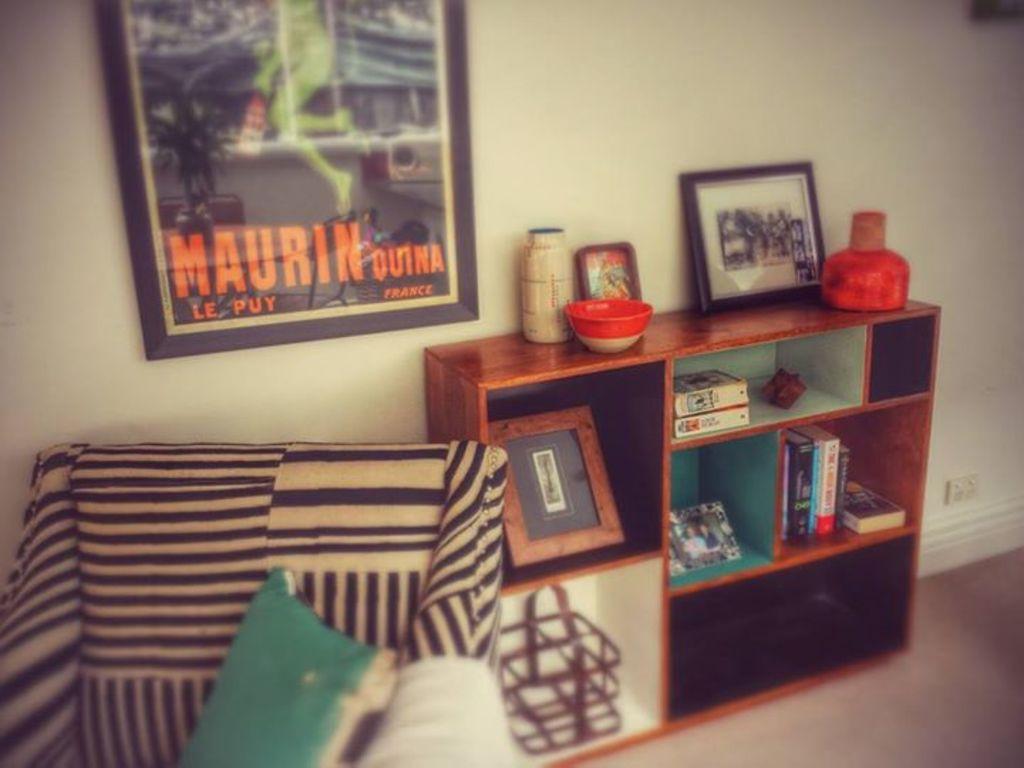What is the largest text in the picture?
Provide a succinct answer. Maurin. 